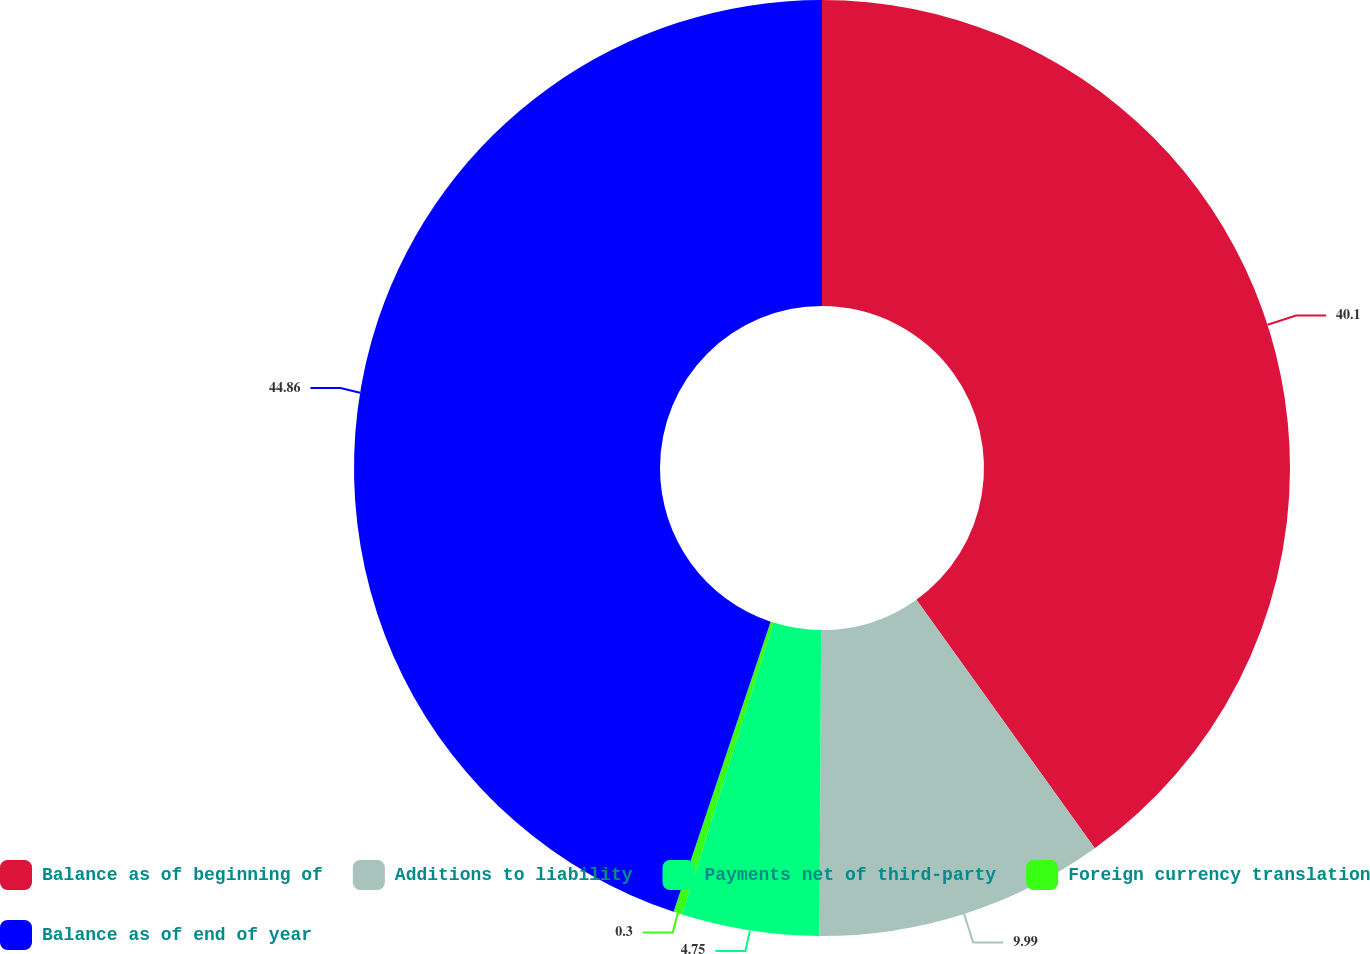Convert chart to OTSL. <chart><loc_0><loc_0><loc_500><loc_500><pie_chart><fcel>Balance as of beginning of<fcel>Additions to liability<fcel>Payments net of third-party<fcel>Foreign currency translation<fcel>Balance as of end of year<nl><fcel>40.1%<fcel>9.99%<fcel>4.75%<fcel>0.3%<fcel>44.87%<nl></chart> 